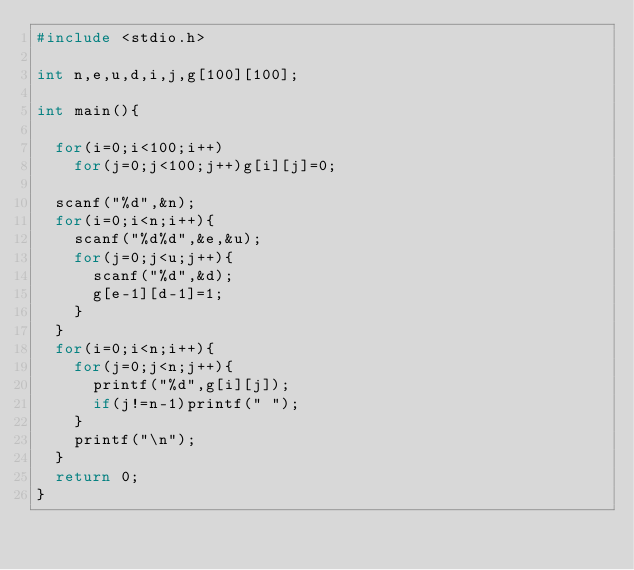<code> <loc_0><loc_0><loc_500><loc_500><_C_>#include <stdio.h>
 
int n,e,u,d,i,j,g[100][100];
 
int main(){
 
  for(i=0;i<100;i++)
    for(j=0;j<100;j++)g[i][j]=0;
 
  scanf("%d",&n);
  for(i=0;i<n;i++){
    scanf("%d%d",&e,&u);
    for(j=0;j<u;j++){
      scanf("%d",&d);
      g[e-1][d-1]=1;
    }
  }
  for(i=0;i<n;i++){
    for(j=0;j<n;j++){
      printf("%d",g[i][j]);
      if(j!=n-1)printf(" ");
    }
    printf("\n");
  }
  return 0;
}

</code> 